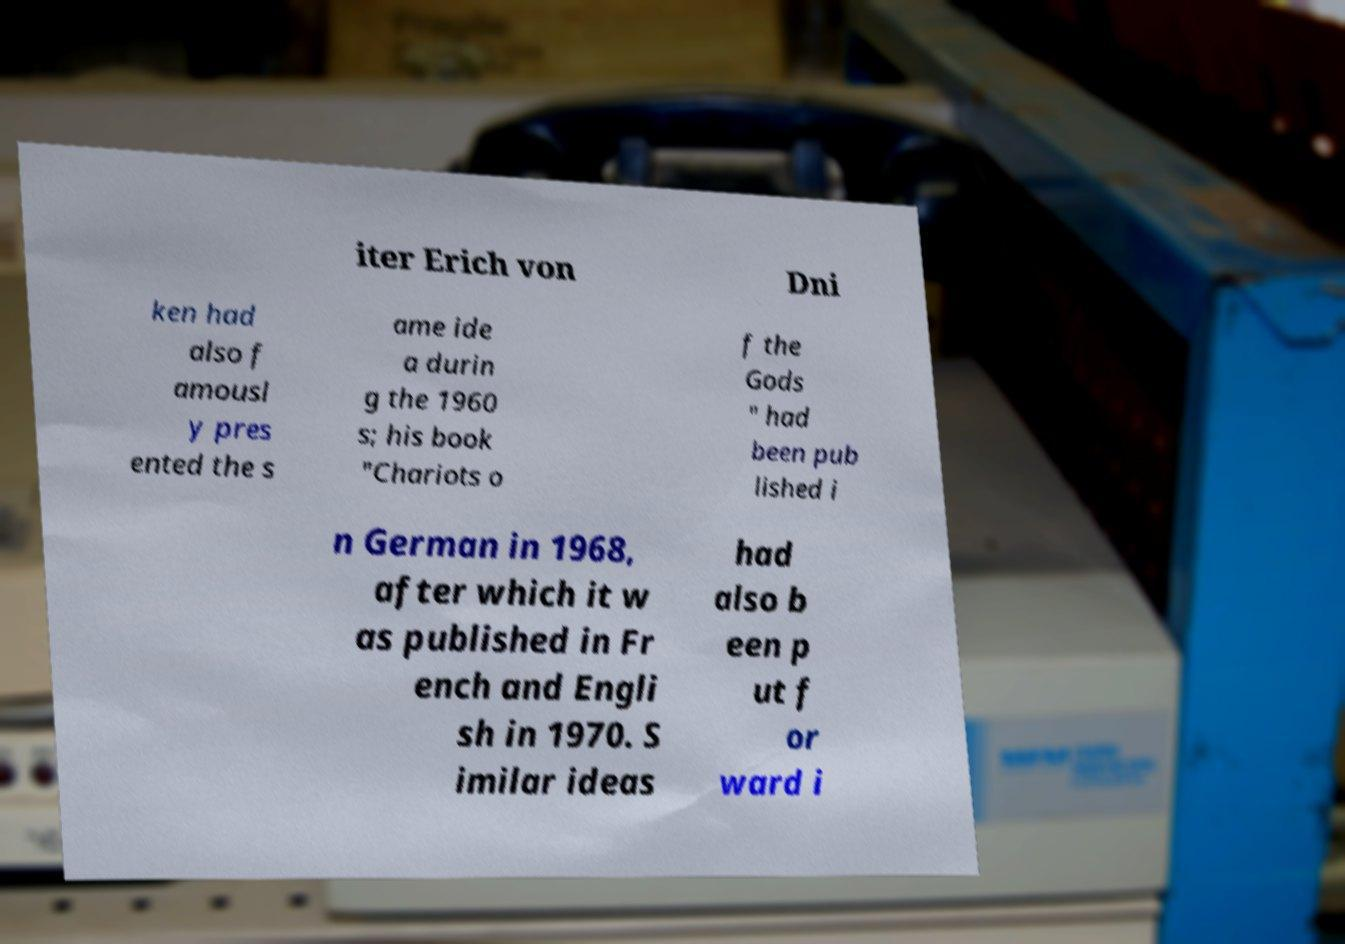Please read and relay the text visible in this image. What does it say? iter Erich von Dni ken had also f amousl y pres ented the s ame ide a durin g the 1960 s; his book "Chariots o f the Gods " had been pub lished i n German in 1968, after which it w as published in Fr ench and Engli sh in 1970. S imilar ideas had also b een p ut f or ward i 